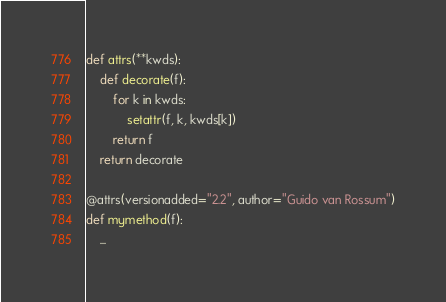<code> <loc_0><loc_0><loc_500><loc_500><_Python_>def attrs(**kwds):
    def decorate(f):
        for k in kwds:
            setattr(f, k, kwds[k])
        return f
    return decorate

@attrs(versionadded="2.2", author="Guido van Rossum")
def mymethod(f):
    ...
</code> 